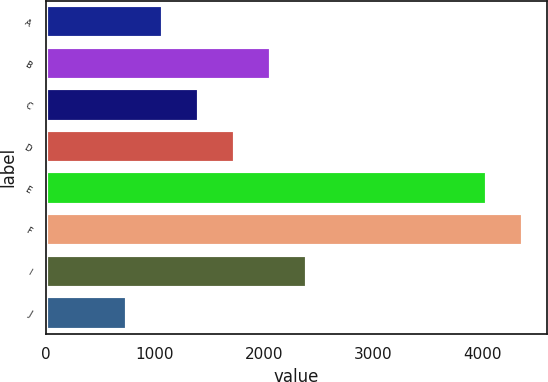<chart> <loc_0><loc_0><loc_500><loc_500><bar_chart><fcel>A<fcel>B<fcel>C<fcel>D<fcel>E<fcel>F<fcel>I<fcel>J<nl><fcel>1074.76<fcel>2064.64<fcel>1404.72<fcel>1734.68<fcel>4044.44<fcel>4374.4<fcel>2394.61<fcel>744.79<nl></chart> 